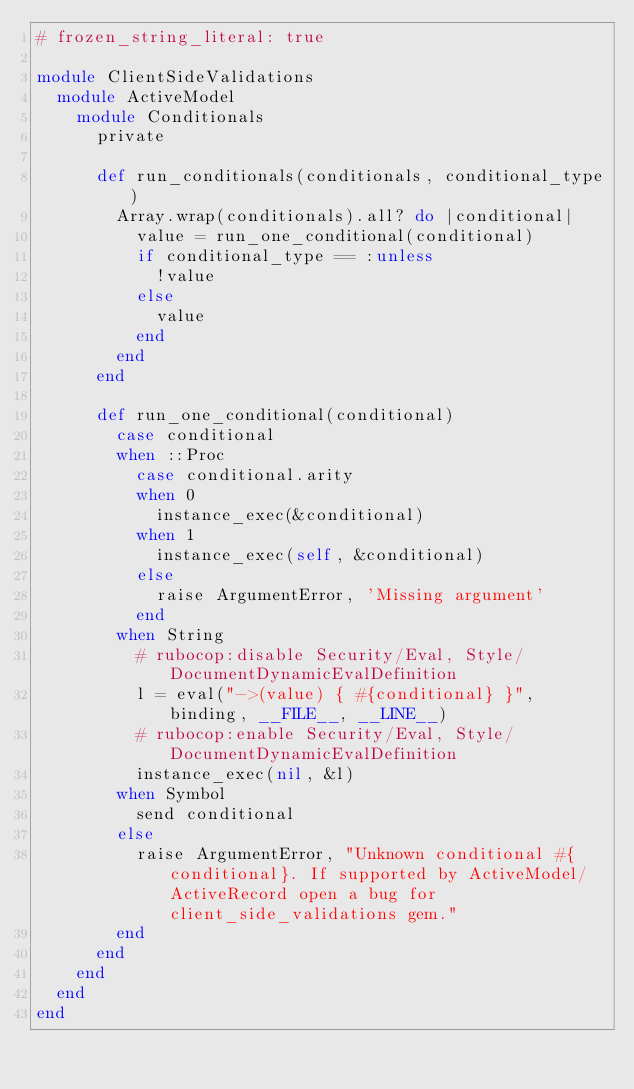<code> <loc_0><loc_0><loc_500><loc_500><_Ruby_># frozen_string_literal: true

module ClientSideValidations
  module ActiveModel
    module Conditionals
      private

      def run_conditionals(conditionals, conditional_type)
        Array.wrap(conditionals).all? do |conditional|
          value = run_one_conditional(conditional)
          if conditional_type == :unless
            !value
          else
            value
          end
        end
      end

      def run_one_conditional(conditional)
        case conditional
        when ::Proc
          case conditional.arity
          when 0
            instance_exec(&conditional)
          when 1
            instance_exec(self, &conditional)
          else
            raise ArgumentError, 'Missing argument'
          end
        when String
          # rubocop:disable Security/Eval, Style/DocumentDynamicEvalDefinition
          l = eval("->(value) { #{conditional} }", binding, __FILE__, __LINE__)
          # rubocop:enable Security/Eval, Style/DocumentDynamicEvalDefinition
          instance_exec(nil, &l)
        when Symbol
          send conditional
        else
          raise ArgumentError, "Unknown conditional #{conditional}. If supported by ActiveModel/ActiveRecord open a bug for client_side_validations gem."
        end
      end
    end
  end
end
</code> 